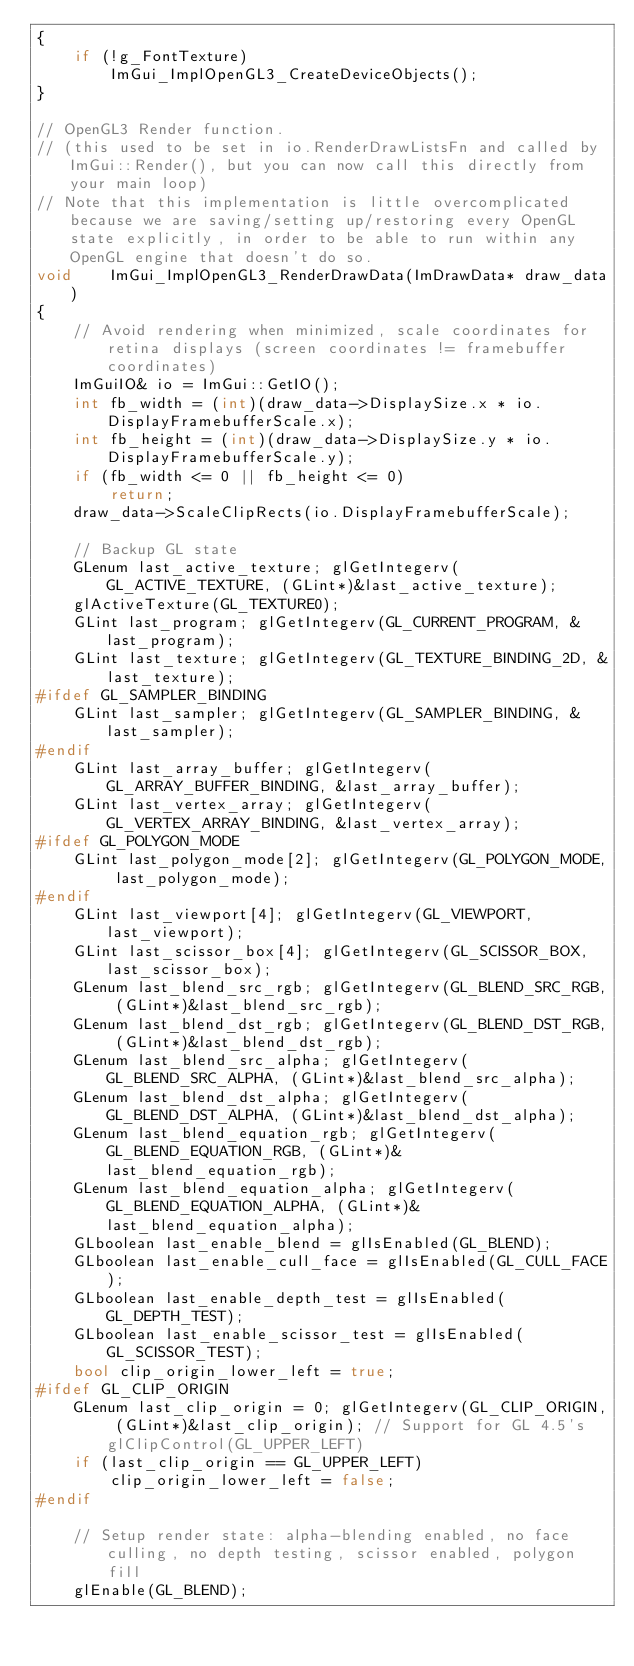<code> <loc_0><loc_0><loc_500><loc_500><_C++_>{
    if (!g_FontTexture)
        ImGui_ImplOpenGL3_CreateDeviceObjects();
}

// OpenGL3 Render function.
// (this used to be set in io.RenderDrawListsFn and called by ImGui::Render(), but you can now call this directly from your main loop)
// Note that this implementation is little overcomplicated because we are saving/setting up/restoring every OpenGL state explicitly, in order to be able to run within any OpenGL engine that doesn't do so.
void    ImGui_ImplOpenGL3_RenderDrawData(ImDrawData* draw_data)
{
    // Avoid rendering when minimized, scale coordinates for retina displays (screen coordinates != framebuffer coordinates)
    ImGuiIO& io = ImGui::GetIO();
    int fb_width = (int)(draw_data->DisplaySize.x * io.DisplayFramebufferScale.x);
    int fb_height = (int)(draw_data->DisplaySize.y * io.DisplayFramebufferScale.y);
    if (fb_width <= 0 || fb_height <= 0)
        return;
    draw_data->ScaleClipRects(io.DisplayFramebufferScale);

    // Backup GL state
    GLenum last_active_texture; glGetIntegerv(GL_ACTIVE_TEXTURE, (GLint*)&last_active_texture);
    glActiveTexture(GL_TEXTURE0);
    GLint last_program; glGetIntegerv(GL_CURRENT_PROGRAM, &last_program);
    GLint last_texture; glGetIntegerv(GL_TEXTURE_BINDING_2D, &last_texture);
#ifdef GL_SAMPLER_BINDING
    GLint last_sampler; glGetIntegerv(GL_SAMPLER_BINDING, &last_sampler);
#endif
    GLint last_array_buffer; glGetIntegerv(GL_ARRAY_BUFFER_BINDING, &last_array_buffer);
    GLint last_vertex_array; glGetIntegerv(GL_VERTEX_ARRAY_BINDING, &last_vertex_array);
#ifdef GL_POLYGON_MODE
    GLint last_polygon_mode[2]; glGetIntegerv(GL_POLYGON_MODE, last_polygon_mode);
#endif
    GLint last_viewport[4]; glGetIntegerv(GL_VIEWPORT, last_viewport);
    GLint last_scissor_box[4]; glGetIntegerv(GL_SCISSOR_BOX, last_scissor_box);
    GLenum last_blend_src_rgb; glGetIntegerv(GL_BLEND_SRC_RGB, (GLint*)&last_blend_src_rgb);
    GLenum last_blend_dst_rgb; glGetIntegerv(GL_BLEND_DST_RGB, (GLint*)&last_blend_dst_rgb);
    GLenum last_blend_src_alpha; glGetIntegerv(GL_BLEND_SRC_ALPHA, (GLint*)&last_blend_src_alpha);
    GLenum last_blend_dst_alpha; glGetIntegerv(GL_BLEND_DST_ALPHA, (GLint*)&last_blend_dst_alpha);
    GLenum last_blend_equation_rgb; glGetIntegerv(GL_BLEND_EQUATION_RGB, (GLint*)&last_blend_equation_rgb);
    GLenum last_blend_equation_alpha; glGetIntegerv(GL_BLEND_EQUATION_ALPHA, (GLint*)&last_blend_equation_alpha);
    GLboolean last_enable_blend = glIsEnabled(GL_BLEND);
    GLboolean last_enable_cull_face = glIsEnabled(GL_CULL_FACE);
    GLboolean last_enable_depth_test = glIsEnabled(GL_DEPTH_TEST);
    GLboolean last_enable_scissor_test = glIsEnabled(GL_SCISSOR_TEST);
    bool clip_origin_lower_left = true;
#ifdef GL_CLIP_ORIGIN
    GLenum last_clip_origin = 0; glGetIntegerv(GL_CLIP_ORIGIN, (GLint*)&last_clip_origin); // Support for GL 4.5's glClipControl(GL_UPPER_LEFT)
    if (last_clip_origin == GL_UPPER_LEFT)
        clip_origin_lower_left = false;
#endif

    // Setup render state: alpha-blending enabled, no face culling, no depth testing, scissor enabled, polygon fill
    glEnable(GL_BLEND);</code> 